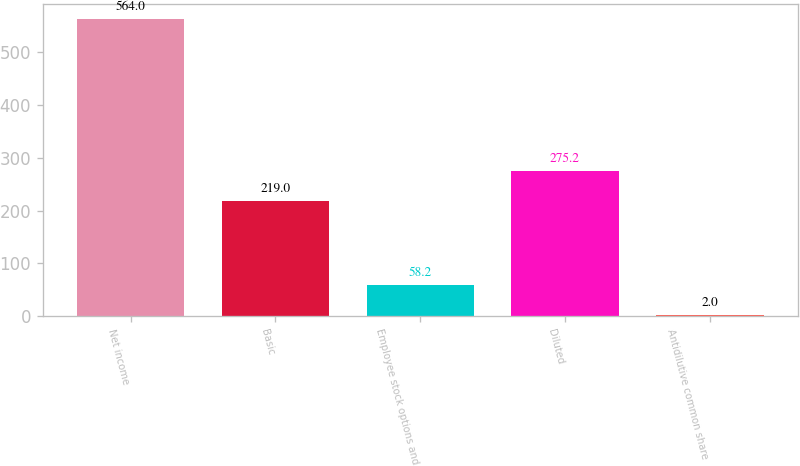<chart> <loc_0><loc_0><loc_500><loc_500><bar_chart><fcel>Net income<fcel>Basic<fcel>Employee stock options and<fcel>Diluted<fcel>Antidilutive common share<nl><fcel>564<fcel>219<fcel>58.2<fcel>275.2<fcel>2<nl></chart> 